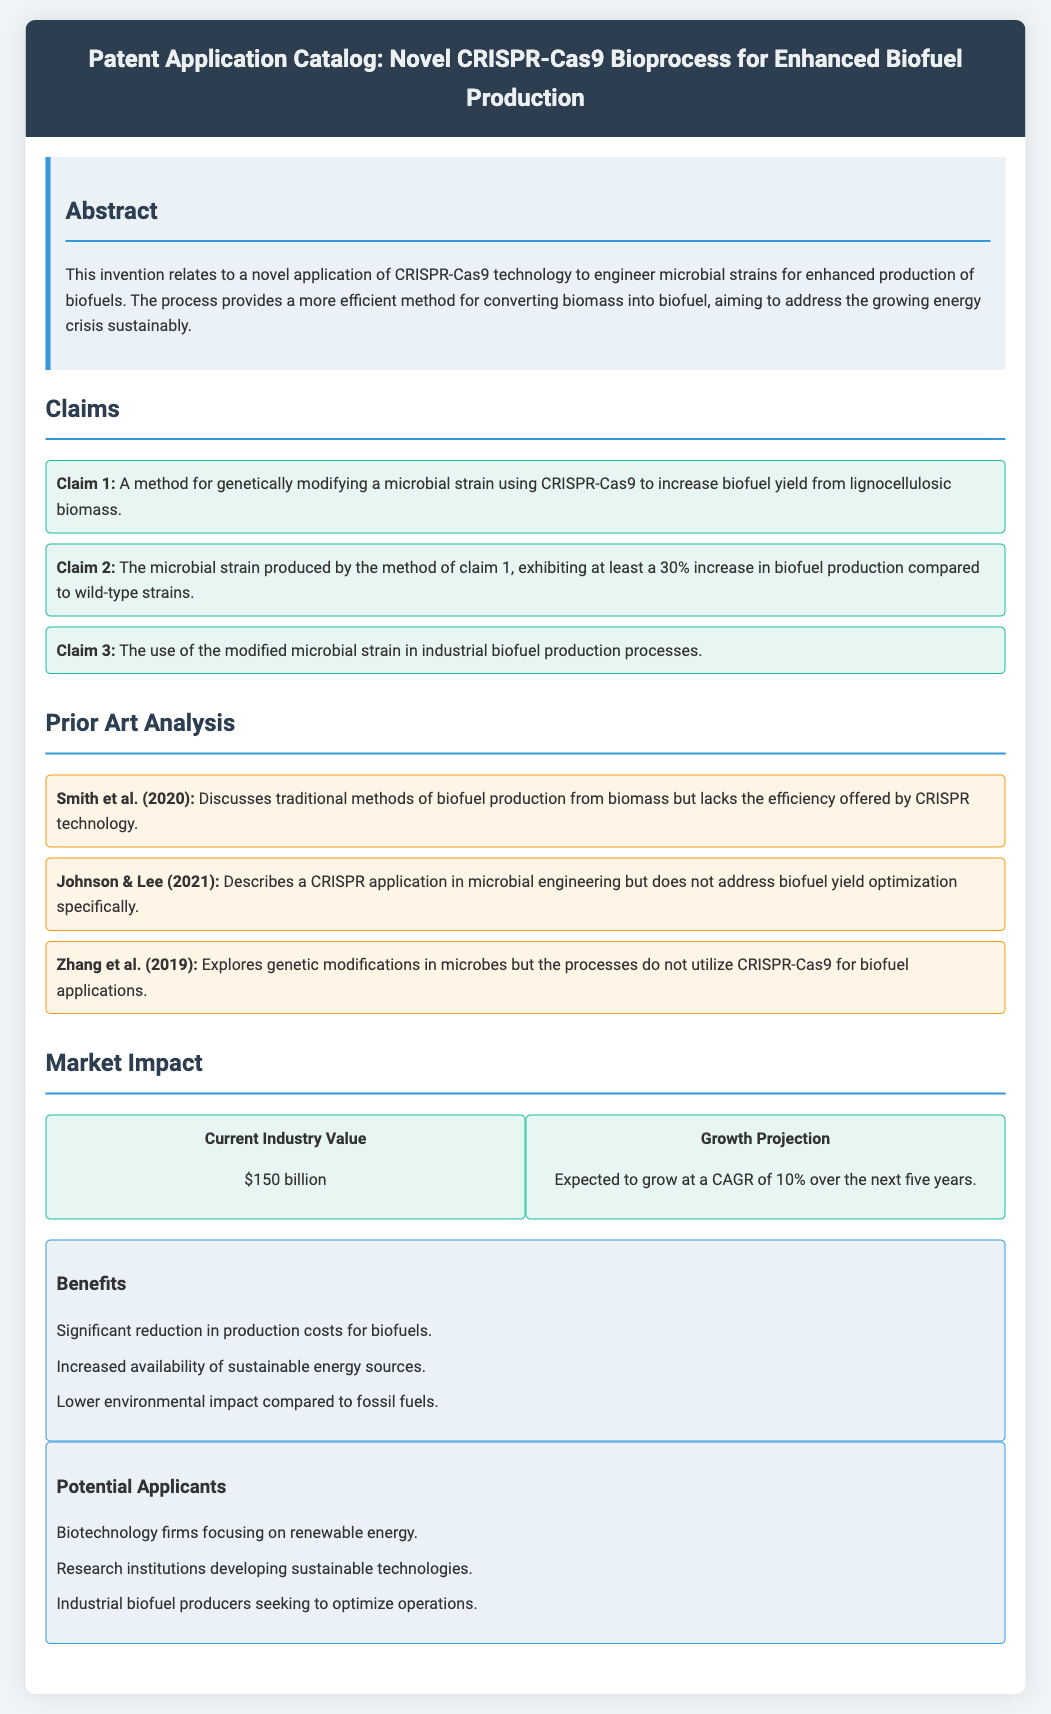What is the title of the patent application? The title is stated at the top of the document, providing the subject of the patent application.
Answer: Novel CRISPR-Cas9 Bioprocess for Enhanced Biofuel Production What is the claimed increase in biofuel production? The claim regarding the increase in biofuel production is specifically mentioned in Claim 2 of the document.
Answer: 30% Who authored the prior art discussing traditional methods of biofuel production? The author of the mentioned prior art that discusses traditional methods is contained within the text of the prior art analysis section.
Answer: Smith et al. (2020) What is the expected growth rate of the industry over the next five years? The growth projection is categorized under market impact, reflecting industry trends.
Answer: 10% What environmental benefit does the process aim to achieve? The benefits section in the market impact highlights specific advantages of the novel process.
Answer: Lower environmental impact compared to fossil fuels How many claims are detailed in the document? The number of claims is determined by counting the individual claims listed in the claims section.
Answer: 3 What are the potential applicants mentioned? The potential applicants for the biotechnology process are listed under the market impact section of the document.
Answer: Biotechnology firms focusing on renewable energy What is the current industry value provided in the document? The current industry value is shown as a statistic within the market impact section.
Answer: $150 billion Which technology is used for genetic modification in the process? The technology used for genetic modification is noted in the abstract where the innovative method is introduced.
Answer: CRISPR-Cas9 